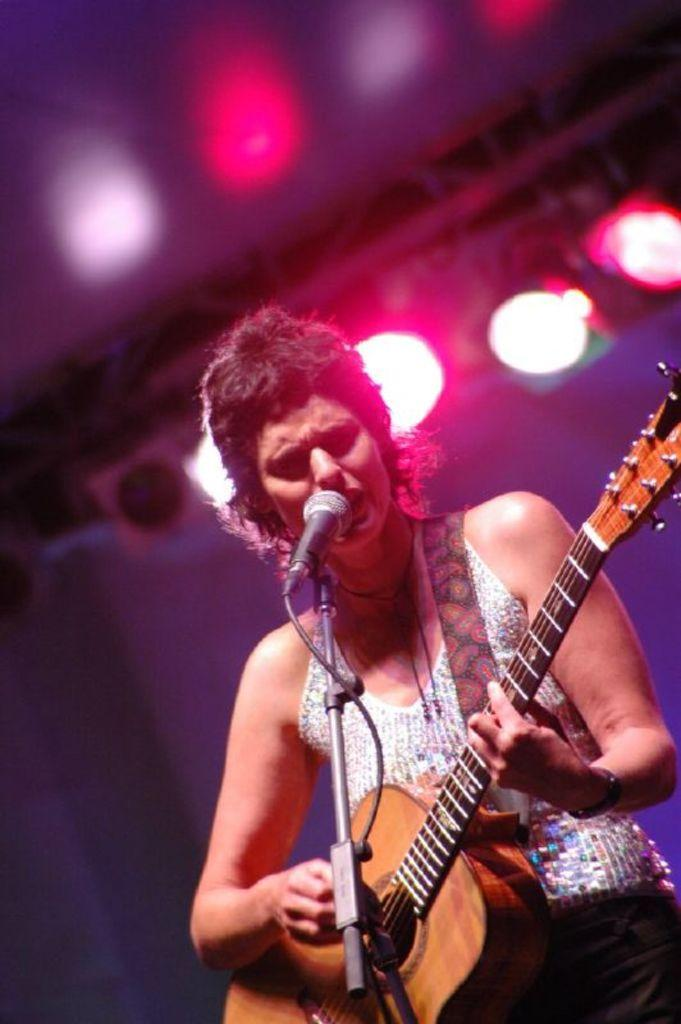What is the person in the image doing? The person is holding a guitar. What object is the person standing in front of? The person is in front of a microphone. What can be seen in the background of the image? There are lights visible in the background of the image. What direction is the person coughing in the image? There is no indication in the image that the person is coughing, so it cannot be determined from the picture. 